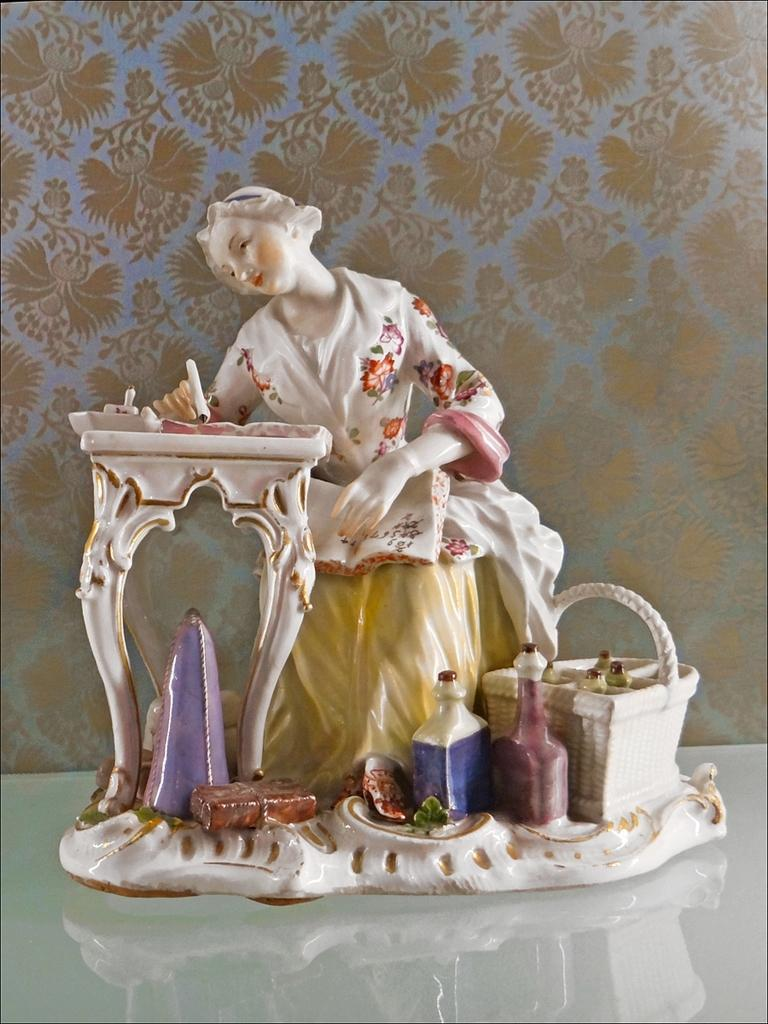What is the main subject of the image? There is a sculpture in the image. What is the sculpture placed on? The sculpture is on a white surface. What type of turkey can be seen hiding behind the curtain in the image? There is no turkey or curtain present in the image; it only features a sculpture on a white surface. 